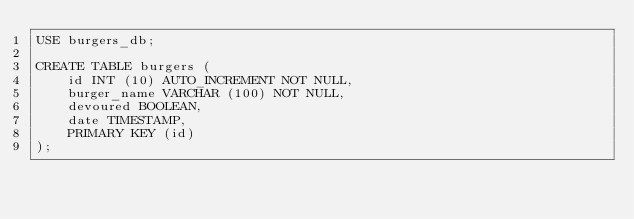Convert code to text. <code><loc_0><loc_0><loc_500><loc_500><_SQL_>USE burgers_db;

CREATE TABLE burgers (
    id INT (10) AUTO_INCREMENT NOT NULL,
    burger_name VARCHAR (100) NOT NULL,
    devoured BOOLEAN,
    date TIMESTAMP,
    PRIMARY KEY (id)
);</code> 